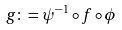<formula> <loc_0><loc_0><loc_500><loc_500>g \colon = \psi ^ { - 1 } \circ f \circ \phi</formula> 